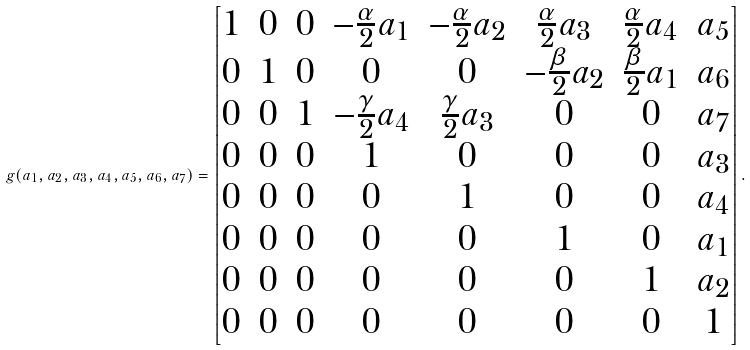Convert formula to latex. <formula><loc_0><loc_0><loc_500><loc_500>g ( a _ { 1 } , a _ { 2 } , a _ { 3 } , a _ { 4 } , a _ { 5 } , a _ { 6 } , a _ { 7 } ) = \begin{bmatrix} 1 & 0 & 0 & - \frac { \alpha } { 2 } a _ { 1 } & - \frac { \alpha } { 2 } a _ { 2 } & \frac { \alpha } { 2 } a _ { 3 } & \frac { \alpha } { 2 } a _ { 4 } & a _ { 5 } \\ 0 & 1 & 0 & 0 & 0 & - \frac { \beta } { 2 } a _ { 2 } & \frac { \beta } { 2 } a _ { 1 } & a _ { 6 } \\ 0 & 0 & 1 & - \frac { \gamma } { 2 } a _ { 4 } & \frac { \gamma } { 2 } a _ { 3 } & 0 & 0 & a _ { 7 } \\ 0 & 0 & 0 & 1 & 0 & 0 & 0 & a _ { 3 } \\ 0 & 0 & 0 & 0 & 1 & 0 & 0 & a _ { 4 } \\ 0 & 0 & 0 & 0 & 0 & 1 & 0 & a _ { 1 } \\ 0 & 0 & 0 & 0 & 0 & 0 & 1 & a _ { 2 } \\ 0 & 0 & 0 & 0 & 0 & 0 & 0 & 1 \end{bmatrix} .</formula> 